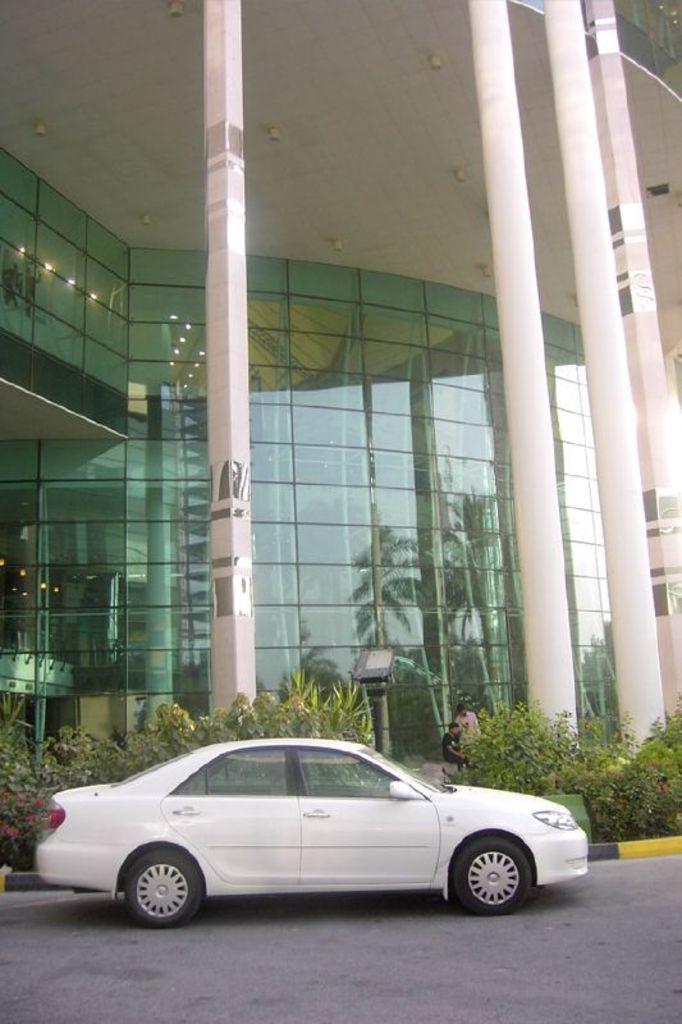Could you give a brief overview of what you see in this image? In this image we can see a building covered with glasses in the front, electric lights to the roof, pillars, plants, bushes, persons standing on the floor and a motor vehicle on the road. 